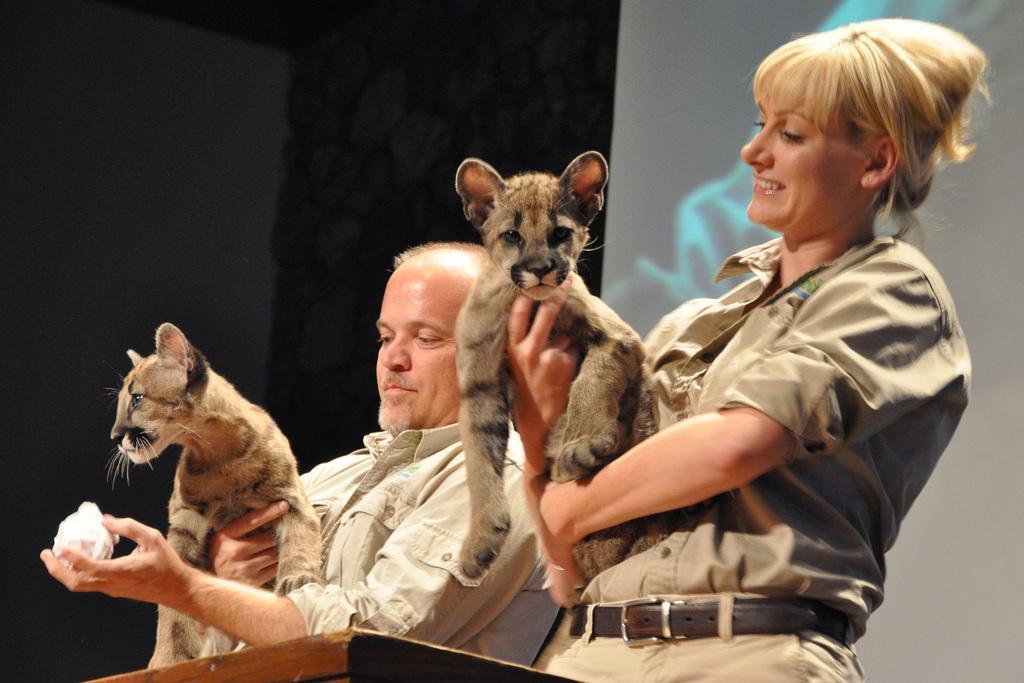How would you summarize this image in a sentence or two? In the picture we can see a man and a woman standing and they are holding animals in their hands and behind them, we can see a wall which is black in color and some part is white in color with some painting on it. 